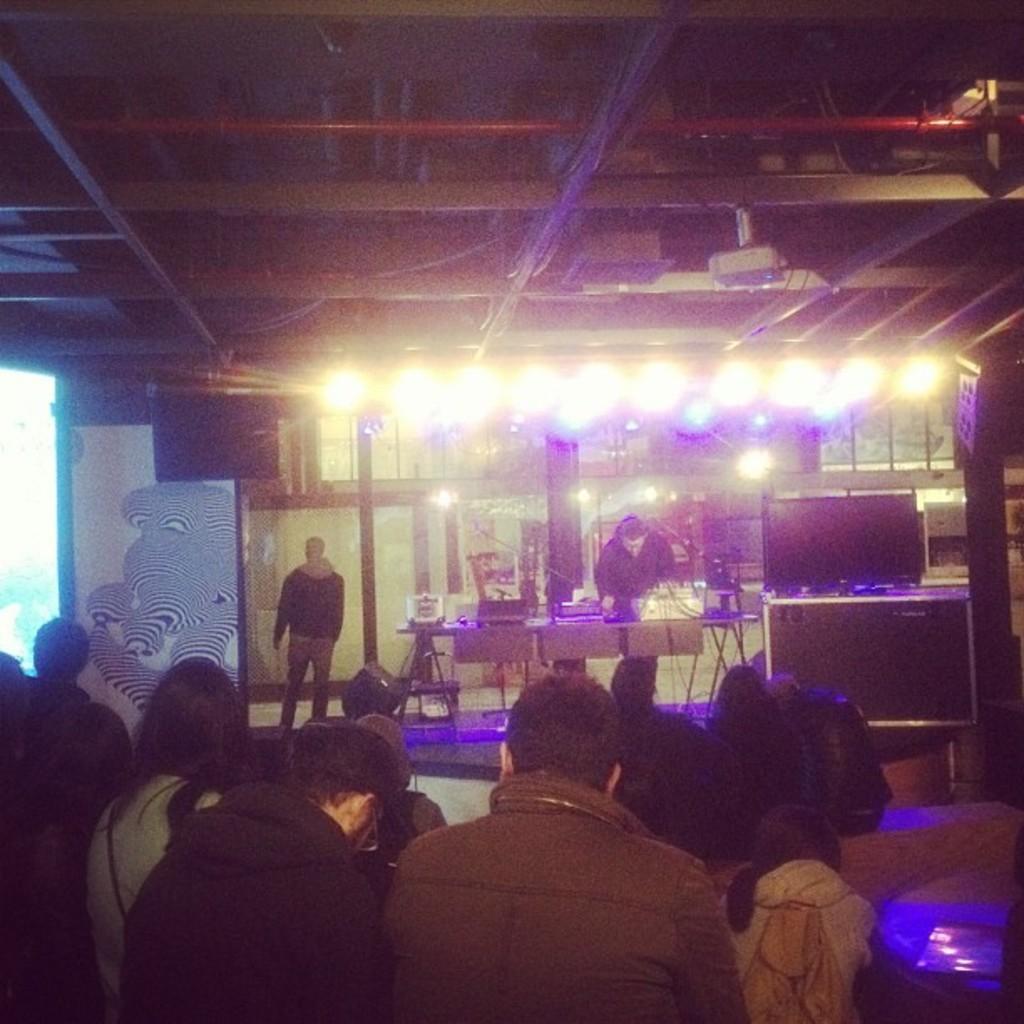How would you summarize this image in a sentence or two? In this image we can see a few people, we can see a table with some objects on it, there are some lights and on the right side we can see a television. 